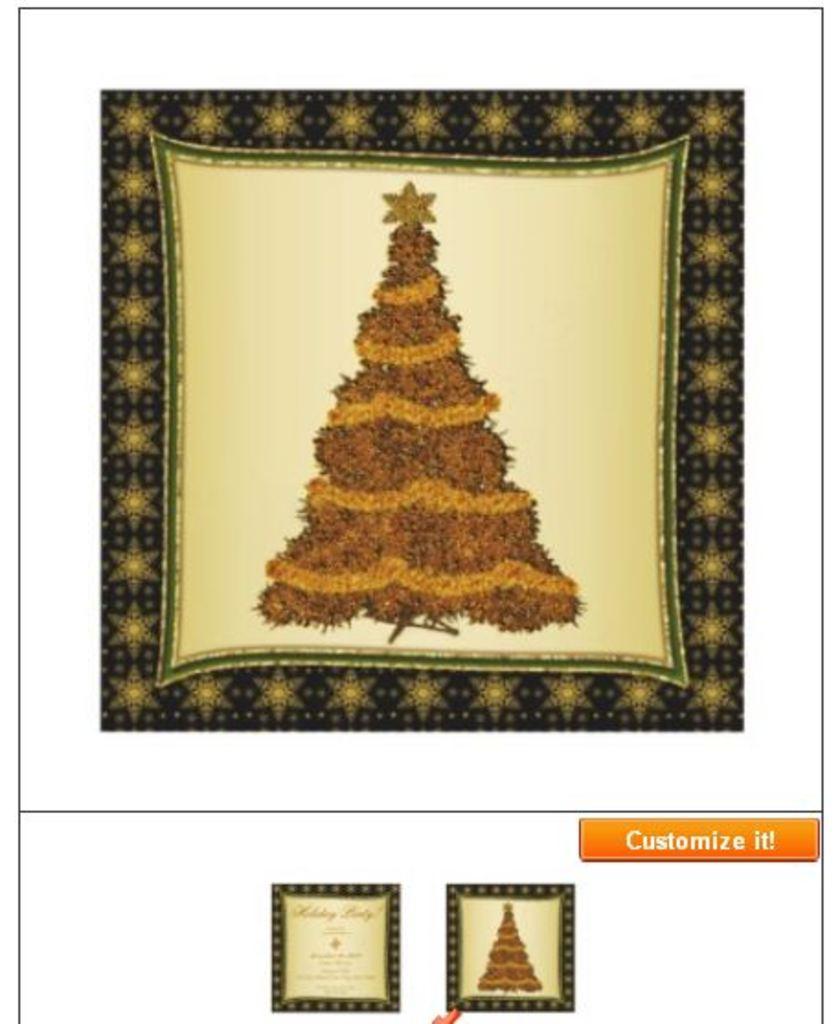How would you summarize this image in a sentence or two? In this image I can see a frame which is black , cream, brown and orange in color. I can see a christmas tree which is brown and orange in color and a star on it. I can see two other frames to the bottom of the image and some thing is written on the image. 